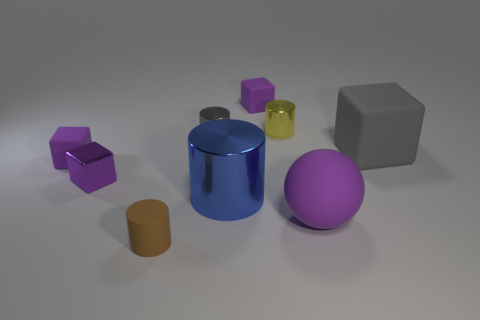How many purple blocks must be subtracted to get 1 purple blocks? 2 Subtract all small yellow metallic cylinders. How many cylinders are left? 3 Subtract all purple cubes. How many cubes are left? 1 Subtract 1 cylinders. How many cylinders are left? 3 Subtract all blue spheres. Subtract all blue cubes. How many spheres are left? 1 Subtract all gray spheres. How many purple cubes are left? 3 Subtract all large purple matte blocks. Subtract all big purple objects. How many objects are left? 8 Add 7 large purple rubber balls. How many large purple rubber balls are left? 8 Add 9 large gray rubber things. How many large gray rubber things exist? 10 Subtract 0 purple cylinders. How many objects are left? 9 